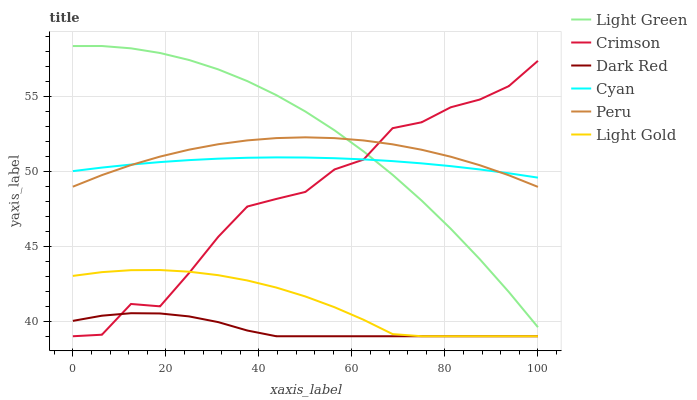Does Dark Red have the minimum area under the curve?
Answer yes or no. Yes. Does Light Green have the maximum area under the curve?
Answer yes or no. Yes. Does Peru have the minimum area under the curve?
Answer yes or no. No. Does Peru have the maximum area under the curve?
Answer yes or no. No. Is Cyan the smoothest?
Answer yes or no. Yes. Is Crimson the roughest?
Answer yes or no. Yes. Is Dark Red the smoothest?
Answer yes or no. No. Is Dark Red the roughest?
Answer yes or no. No. Does Dark Red have the lowest value?
Answer yes or no. Yes. Does Peru have the lowest value?
Answer yes or no. No. Does Light Green have the highest value?
Answer yes or no. Yes. Does Peru have the highest value?
Answer yes or no. No. Is Dark Red less than Peru?
Answer yes or no. Yes. Is Cyan greater than Light Gold?
Answer yes or no. Yes. Does Light Green intersect Crimson?
Answer yes or no. Yes. Is Light Green less than Crimson?
Answer yes or no. No. Is Light Green greater than Crimson?
Answer yes or no. No. Does Dark Red intersect Peru?
Answer yes or no. No. 